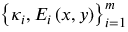<formula> <loc_0><loc_0><loc_500><loc_500>\left \{ \kappa _ { i } , E _ { i } \left ( x , y \right ) \right \} _ { i = 1 } ^ { m }</formula> 